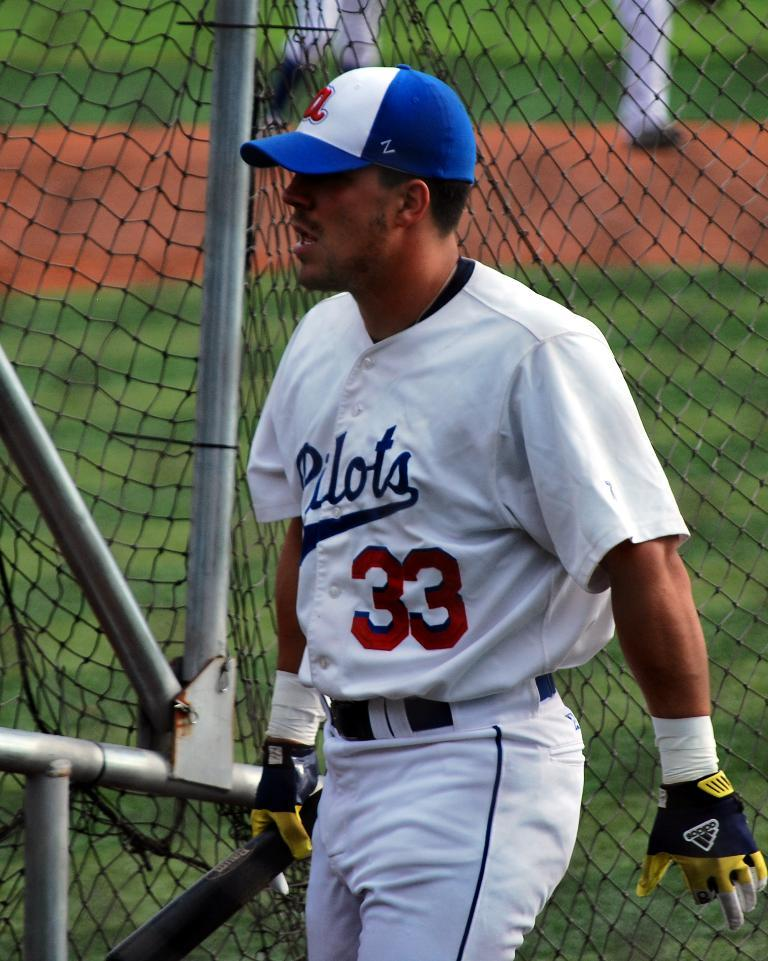Provide a one-sentence caption for the provided image. A baseball player in a white uniform for the team the "Pilots" wearing number 33. 